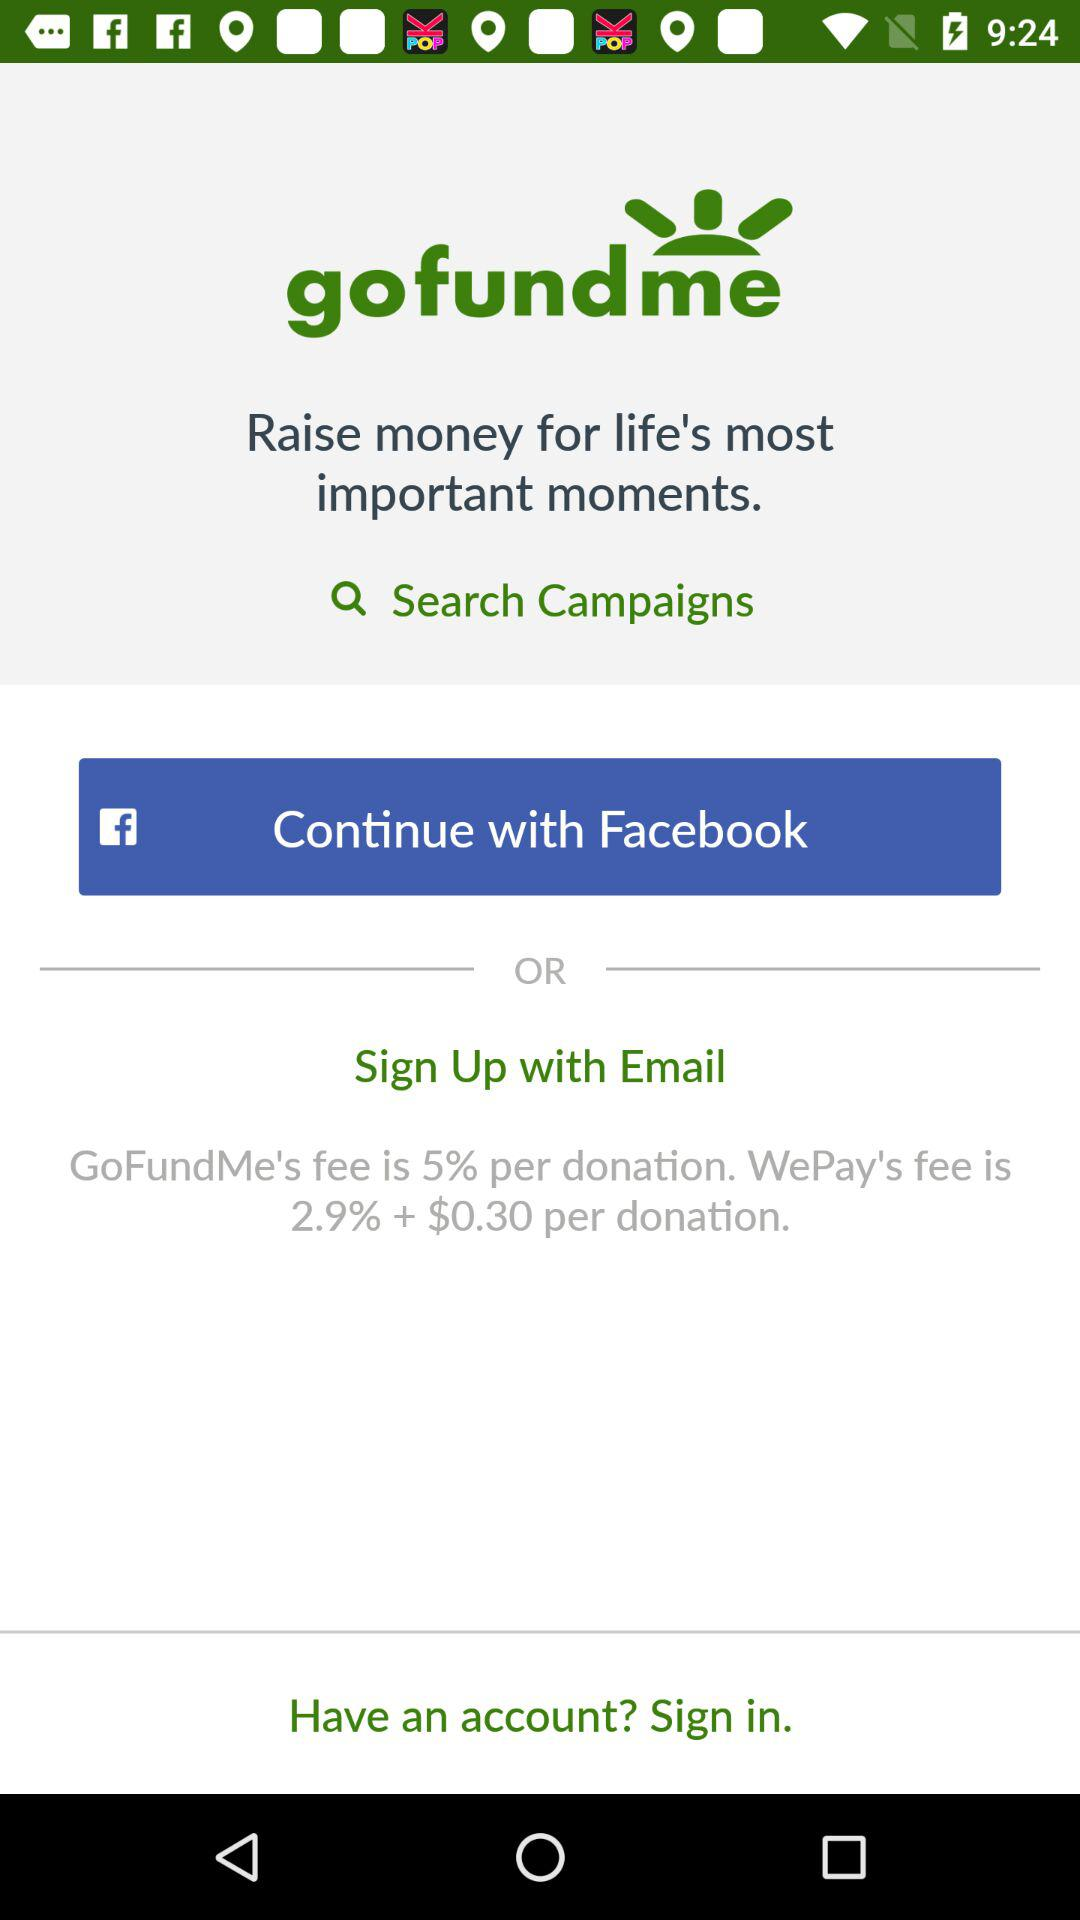What app can we continue with? You can continue with "Facebook". 